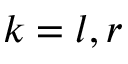Convert formula to latex. <formula><loc_0><loc_0><loc_500><loc_500>k = l , r</formula> 